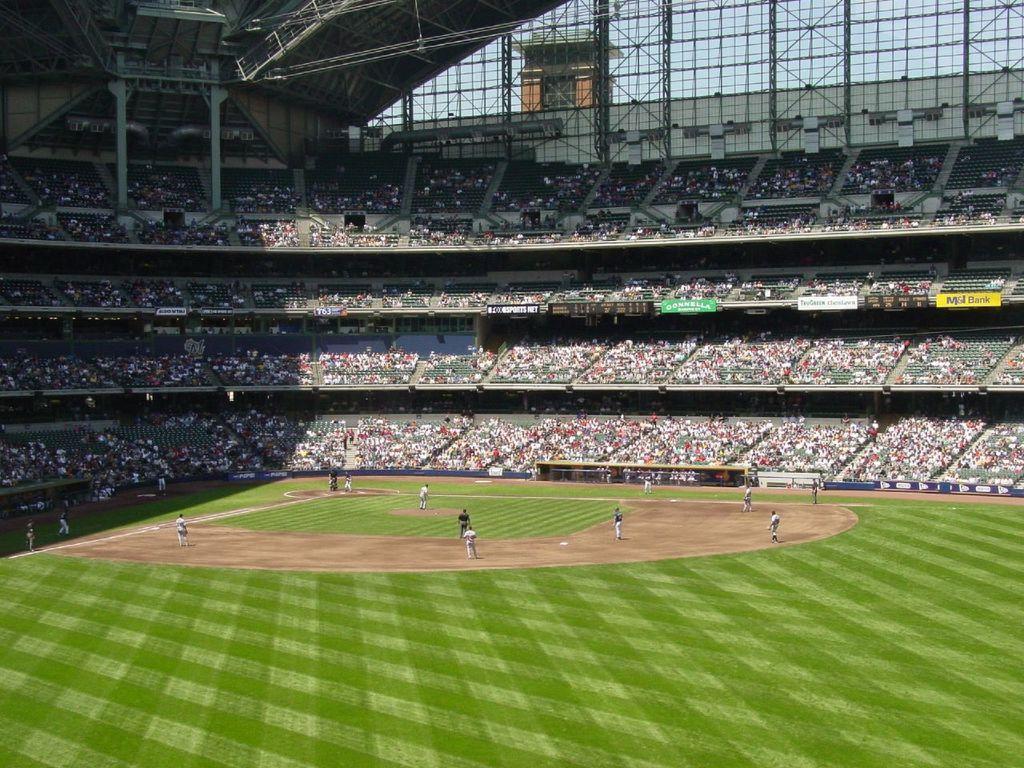Can you describe this image briefly? In this image there are a few players playing the baseball on the ground. Around them there are a few spectators on the stand. In the background of the image there are rooftops supported by metal rods. Behind the metal rods there is a tower. There is sky. 